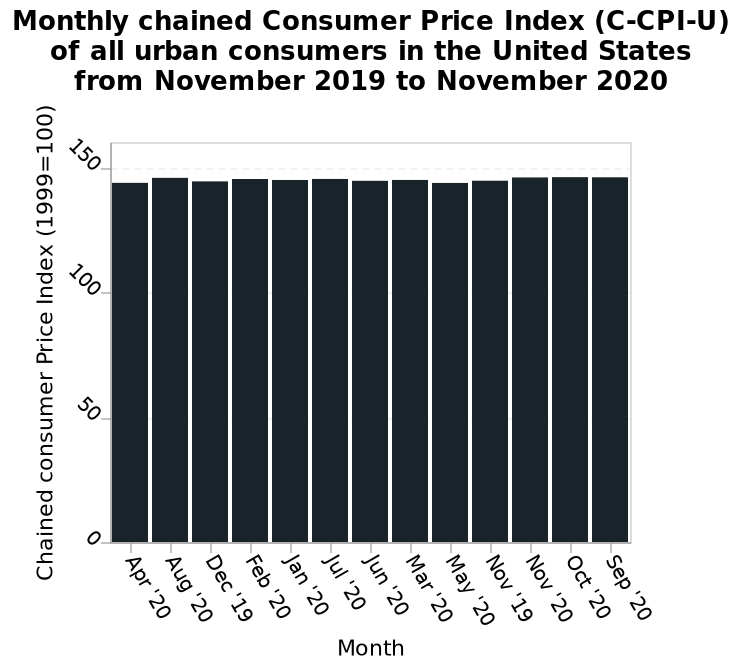<image>
What is the specific type of Consumer Price Index shown in the diagram? The specific type of Consumer Price Index shown is the Monthly Chained Consumer Price Index (C-CPI-U) of all urban consumers. What does the x-axis represent on the bar diagram? The x-axis represents the months from April 2020 to September 2020. How does the consumer price index typically vary from one month to another?  The consumer price index tends to remain relatively stable from one month to another. Does the consumer price index exhibit significant changes on a monthly basis? No, the consumer price index does not exhibit significant changes on a monthly basis. Is the specific type of Consumer Price Index shown the Yearly Unchained Consumer Price Index (UCPI) of rural consumers? No.The specific type of Consumer Price Index shown is the Monthly Chained Consumer Price Index (C-CPI-U) of all urban consumers. 